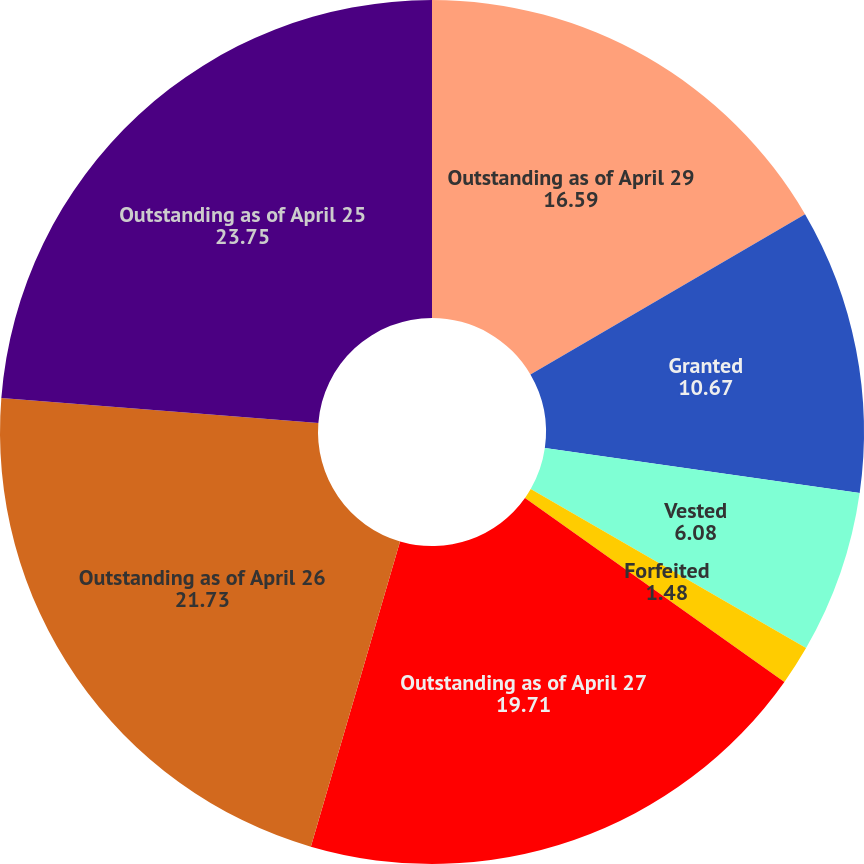<chart> <loc_0><loc_0><loc_500><loc_500><pie_chart><fcel>Outstanding as of April 29<fcel>Granted<fcel>Vested<fcel>Forfeited<fcel>Outstanding as of April 27<fcel>Outstanding as of April 26<fcel>Outstanding as of April 25<nl><fcel>16.59%<fcel>10.67%<fcel>6.08%<fcel>1.48%<fcel>19.71%<fcel>21.73%<fcel>23.75%<nl></chart> 